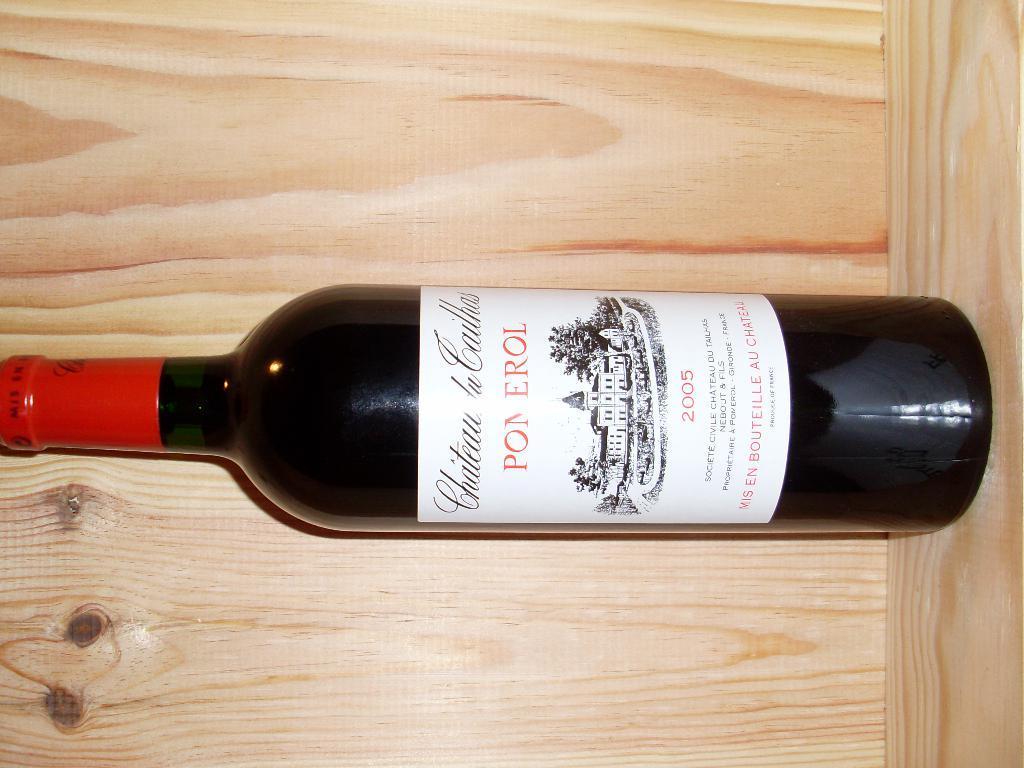Can you describe this image briefly? In the center we can see one wine bottle on the table. In the background there is a wood wall. 